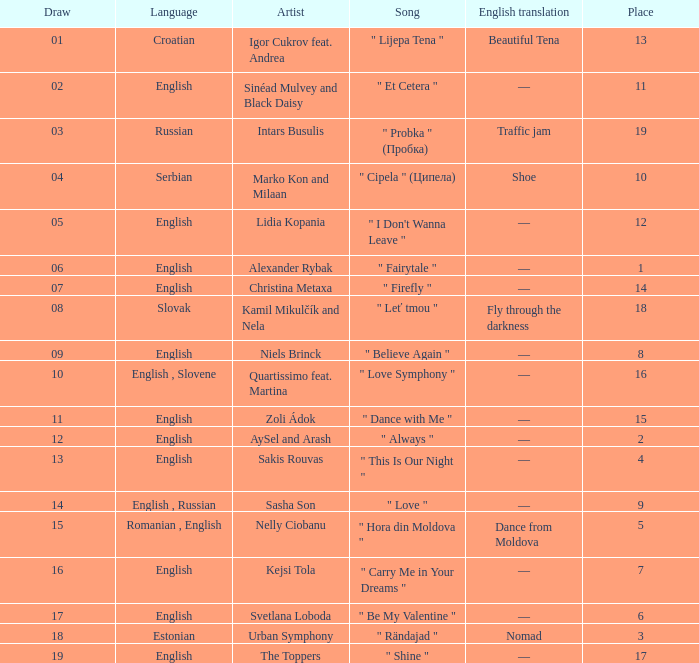What is the place when the draw is less than 12 and the artist is quartissimo feat. martina? 16.0. 